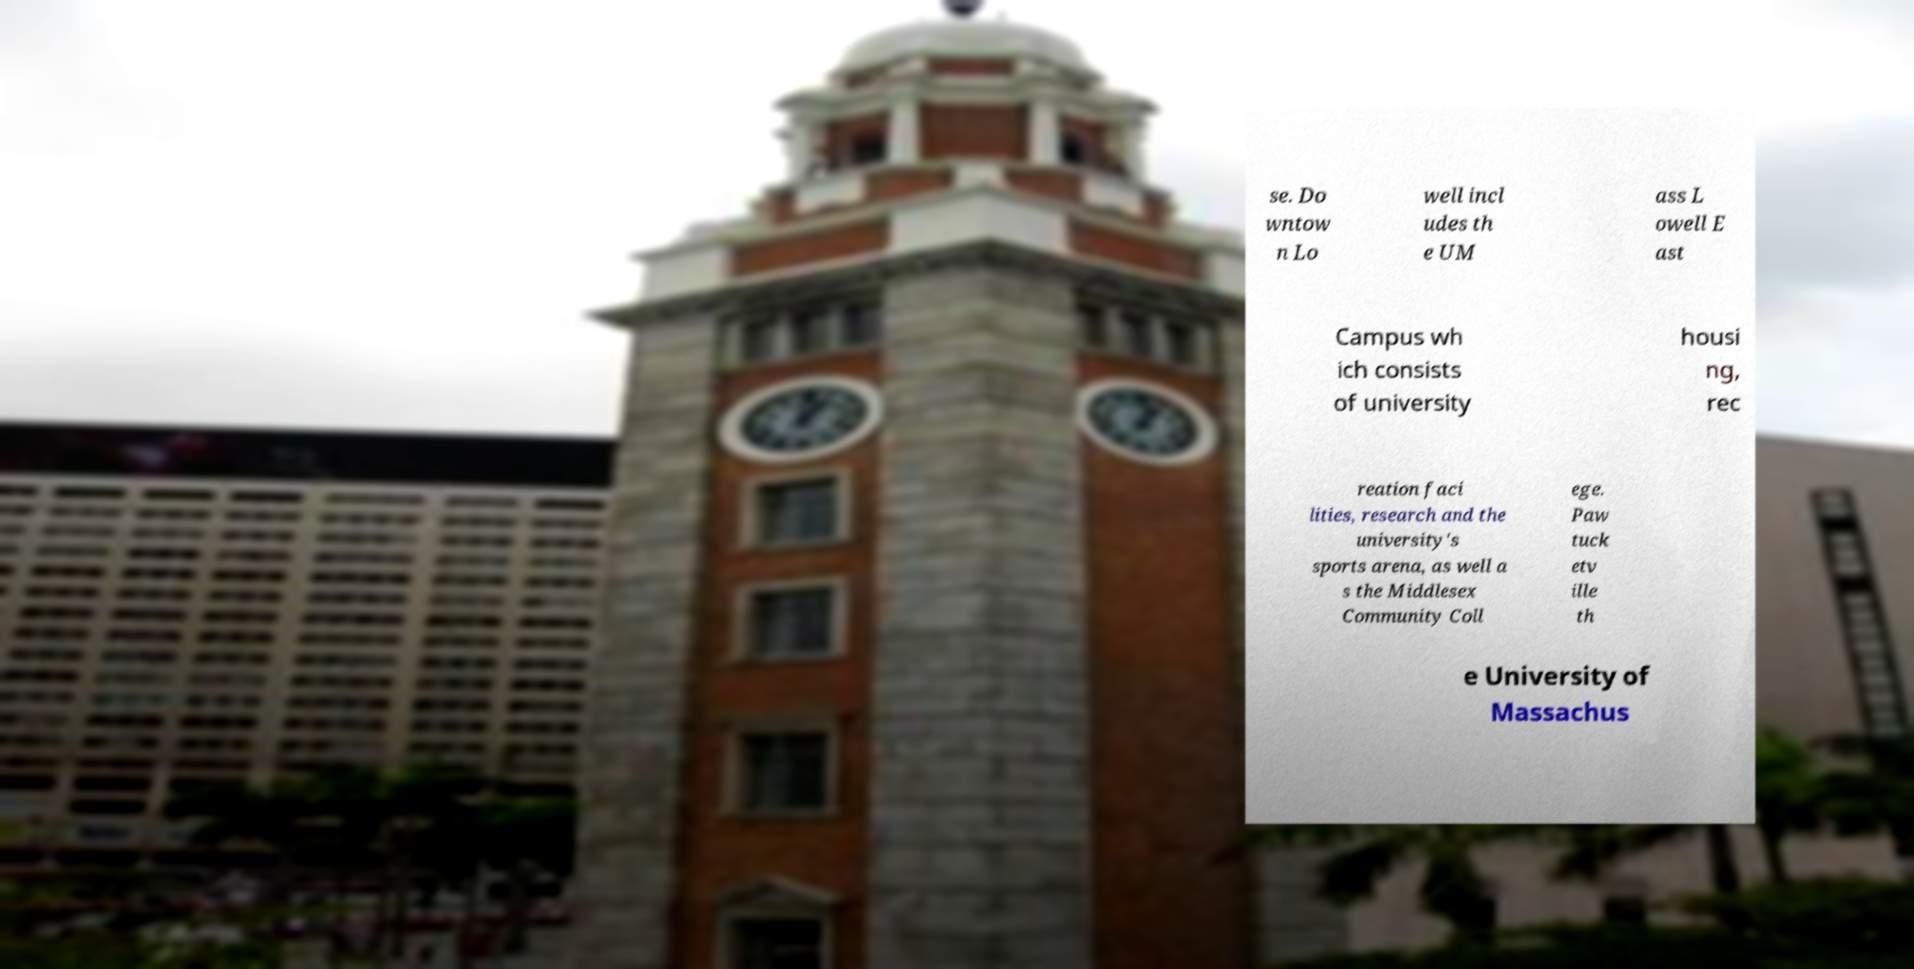For documentation purposes, I need the text within this image transcribed. Could you provide that? se. Do wntow n Lo well incl udes th e UM ass L owell E ast Campus wh ich consists of university housi ng, rec reation faci lities, research and the university's sports arena, as well a s the Middlesex Community Coll ege. Paw tuck etv ille th e University of Massachus 